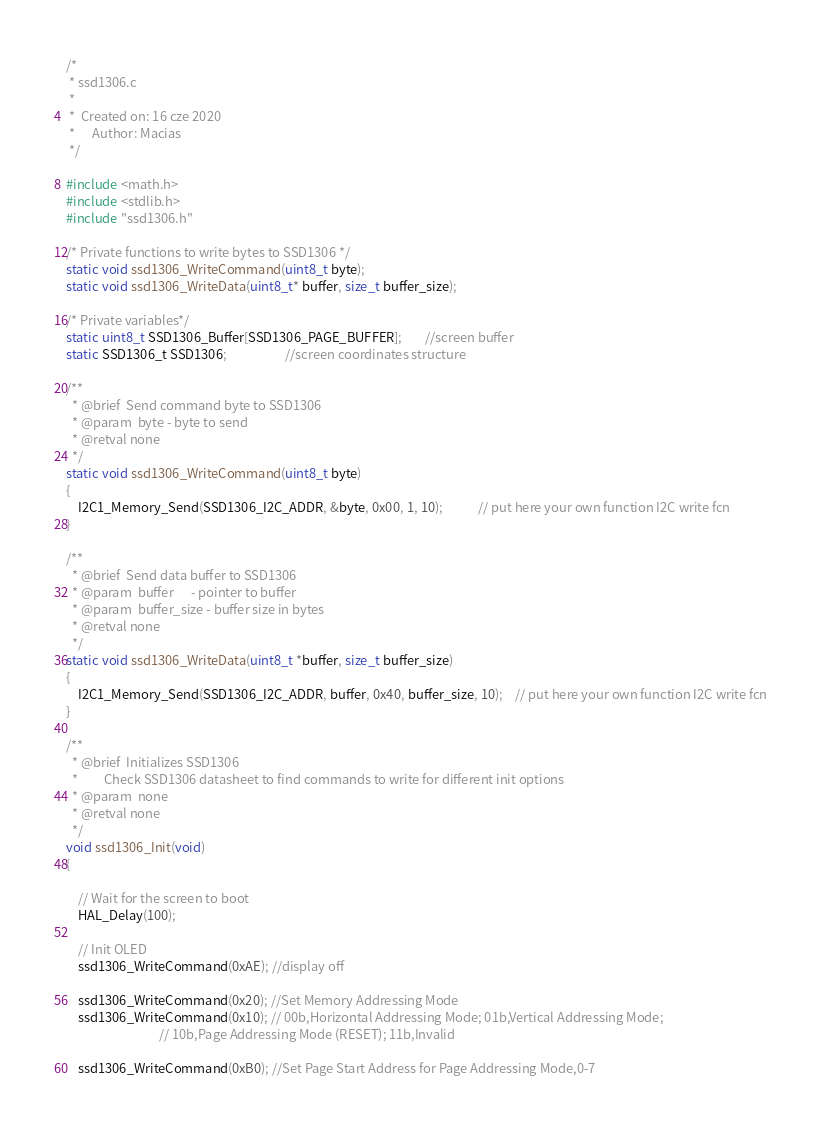<code> <loc_0><loc_0><loc_500><loc_500><_C_>/*
 * ssd1306.c
 *
 *  Created on: 16 cze 2020
 *      Author: Macias
 */

#include <math.h>
#include <stdlib.h>
#include "ssd1306.h"

/* Private functions to write bytes to SSD1306 */
static void ssd1306_WriteCommand(uint8_t byte);
static void ssd1306_WriteData(uint8_t* buffer, size_t buffer_size);

/* Private variables*/
static uint8_t SSD1306_Buffer[SSD1306_PAGE_BUFFER];		//screen buffer
static SSD1306_t SSD1306;					//screen coordinates structure

/**
  * @brief  Send command byte to SSD1306
  * @param  byte - byte to send
  * @retval none
  */
static void ssd1306_WriteCommand(uint8_t byte)
{
	I2C1_Memory_Send(SSD1306_I2C_ADDR, &byte, 0x00, 1, 10);			// put here your own function I2C write fcn
}

/**
  * @brief  Send data buffer to SSD1306
  * @param  buffer 		- pointer to buffer
  * @param  buffer_size - buffer size in bytes
  * @retval none
  */
static void ssd1306_WriteData(uint8_t *buffer, size_t buffer_size)
{
	I2C1_Memory_Send(SSD1306_I2C_ADDR, buffer, 0x40, buffer_size, 10);	// put here your own function I2C write fcn
}

/**
  * @brief  Initializes SSD1306
  * 		Check SSD1306 datasheet to find commands to write for different init options
  * @param  none
  * @retval none
  */
void ssd1306_Init(void)
{

    // Wait for the screen to boot
    HAL_Delay(100);

    // Init OLED
    ssd1306_WriteCommand(0xAE); //display off

    ssd1306_WriteCommand(0x20); //Set Memory Addressing Mode
    ssd1306_WriteCommand(0x10); // 00b,Horizontal Addressing Mode; 01b,Vertical Addressing Mode;
                                // 10b,Page Addressing Mode (RESET); 11b,Invalid

    ssd1306_WriteCommand(0xB0); //Set Page Start Address for Page Addressing Mode,0-7
</code> 